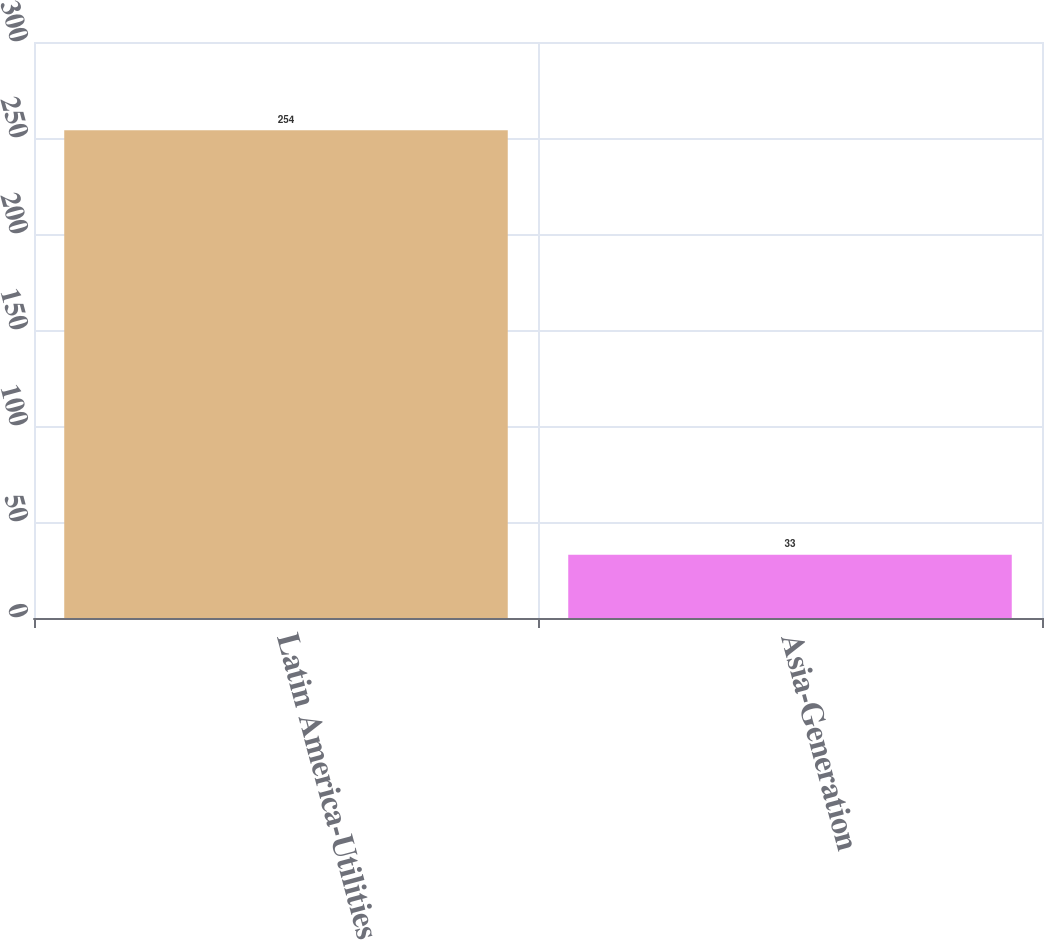<chart> <loc_0><loc_0><loc_500><loc_500><bar_chart><fcel>Latin America-Utilities<fcel>Asia-Generation<nl><fcel>254<fcel>33<nl></chart> 